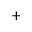Convert formula to latex. <formula><loc_0><loc_0><loc_500><loc_500>^ { + }</formula> 